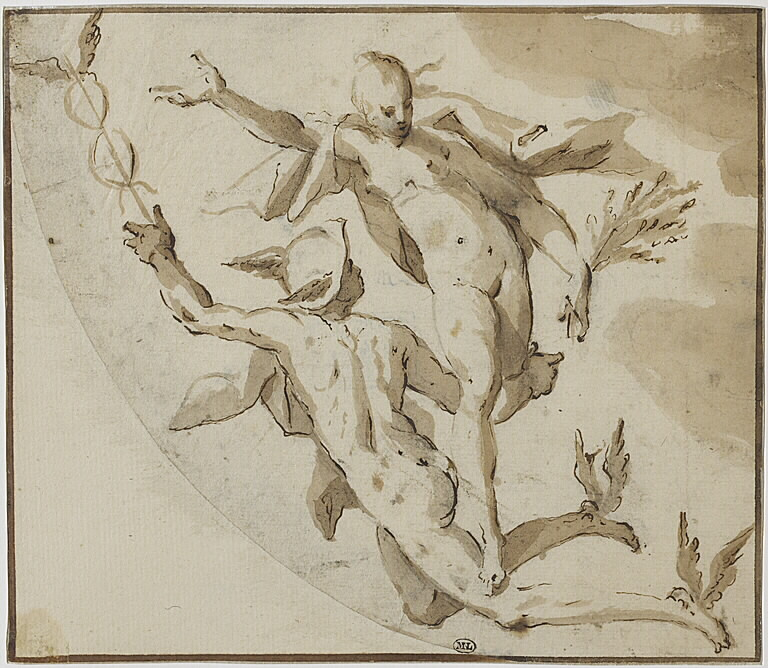Can you describe the materials and techniques that might have been used to create this artwork? This artwork appears to be executed using ink and wash on paper. The ink provides the sharp, definitive lines that delineate the figures and their poses, while the wash adds tonal variation, creating depth and a sense of three-dimensionality. The loose, sketchy style indicates that it may be a preparatory drawing, which artists often used to plan larger, more detailed compositions. The choice of materials and techniques allows the artist to quickly and effectively capture the essence and movement of the scene. 